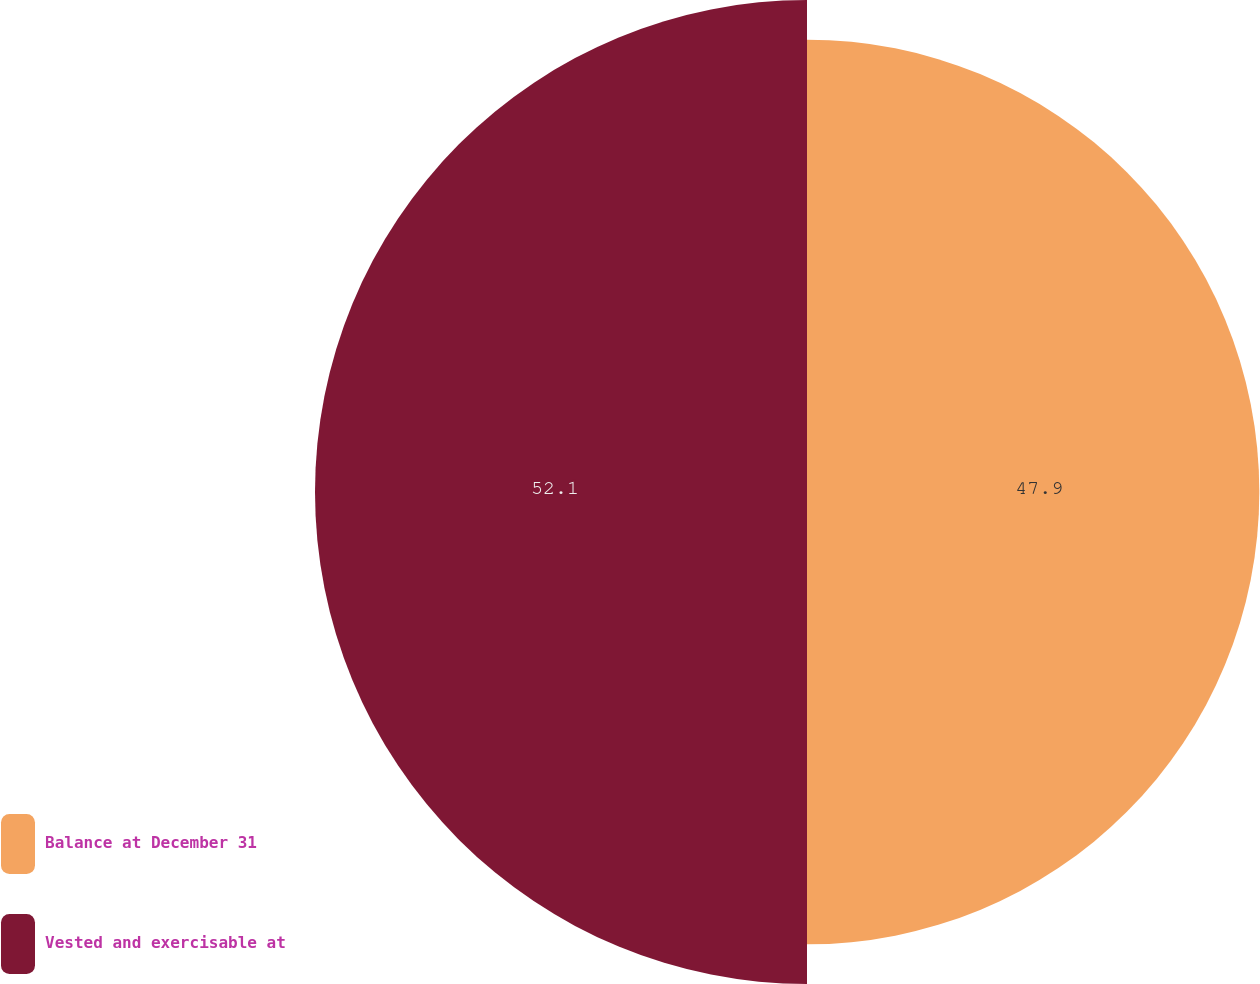<chart> <loc_0><loc_0><loc_500><loc_500><pie_chart><fcel>Balance at December 31<fcel>Vested and exercisable at<nl><fcel>47.9%<fcel>52.1%<nl></chart> 